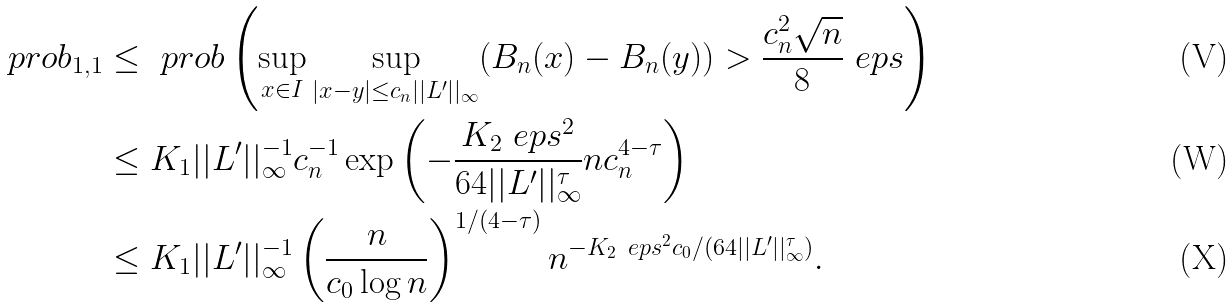<formula> <loc_0><loc_0><loc_500><loc_500>\ p r o b _ { 1 , 1 } & \leq \ p r o b \left ( \sup _ { x \in I } \sup _ { | x - y | \leq c _ { n } | | L ^ { \prime } | | _ { \infty } } ( B _ { n } ( x ) - B _ { n } ( y ) ) > \frac { c _ { n } ^ { 2 } \sqrt { n } } { 8 } \ e p s \right ) \\ & \leq K _ { 1 } | | L ^ { \prime } | | _ { \infty } ^ { - 1 } c _ { n } ^ { - 1 } \exp \left ( - \frac { K _ { 2 } \ e p s ^ { 2 } } { 6 4 | | L ^ { \prime } | | _ { \infty } ^ { \tau } } n c _ { n } ^ { 4 - \tau } \right ) \\ & \leq K _ { 1 } | | L ^ { \prime } | | _ { \infty } ^ { - 1 } \left ( \frac { n } { c _ { 0 } \log n } \right ) ^ { 1 / ( 4 - \tau ) } n ^ { - K _ { 2 } \ e p s ^ { 2 } c _ { 0 } / ( { 6 4 | | L ^ { \prime } | | _ { \infty } ^ { \tau } ) } } .</formula> 